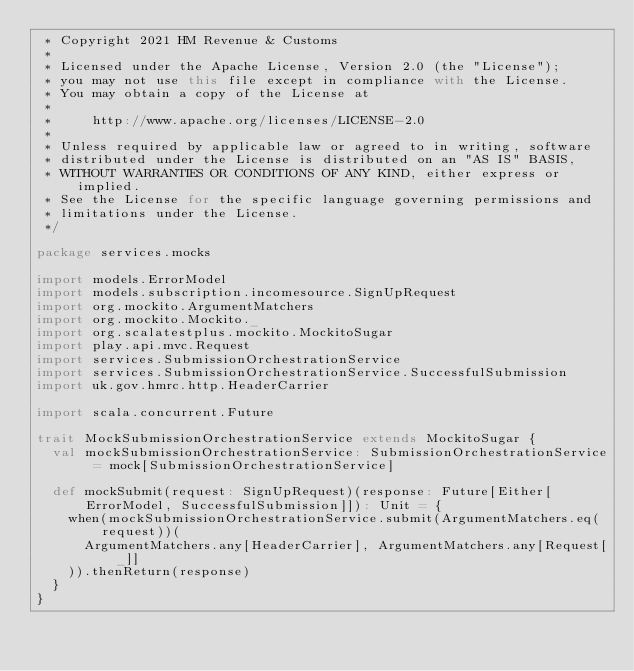Convert code to text. <code><loc_0><loc_0><loc_500><loc_500><_Scala_> * Copyright 2021 HM Revenue & Customs
 *
 * Licensed under the Apache License, Version 2.0 (the "License");
 * you may not use this file except in compliance with the License.
 * You may obtain a copy of the License at
 *
 *     http://www.apache.org/licenses/LICENSE-2.0
 *
 * Unless required by applicable law or agreed to in writing, software
 * distributed under the License is distributed on an "AS IS" BASIS,
 * WITHOUT WARRANTIES OR CONDITIONS OF ANY KIND, either express or implied.
 * See the License for the specific language governing permissions and
 * limitations under the License.
 */

package services.mocks

import models.ErrorModel
import models.subscription.incomesource.SignUpRequest
import org.mockito.ArgumentMatchers
import org.mockito.Mockito._
import org.scalatestplus.mockito.MockitoSugar
import play.api.mvc.Request
import services.SubmissionOrchestrationService
import services.SubmissionOrchestrationService.SuccessfulSubmission
import uk.gov.hmrc.http.HeaderCarrier

import scala.concurrent.Future

trait MockSubmissionOrchestrationService extends MockitoSugar {
  val mockSubmissionOrchestrationService: SubmissionOrchestrationService = mock[SubmissionOrchestrationService]

  def mockSubmit(request: SignUpRequest)(response: Future[Either[ErrorModel, SuccessfulSubmission]]): Unit = {
    when(mockSubmissionOrchestrationService.submit(ArgumentMatchers.eq(request))(
      ArgumentMatchers.any[HeaderCarrier], ArgumentMatchers.any[Request[_]]
    )).thenReturn(response)
  }
}
</code> 